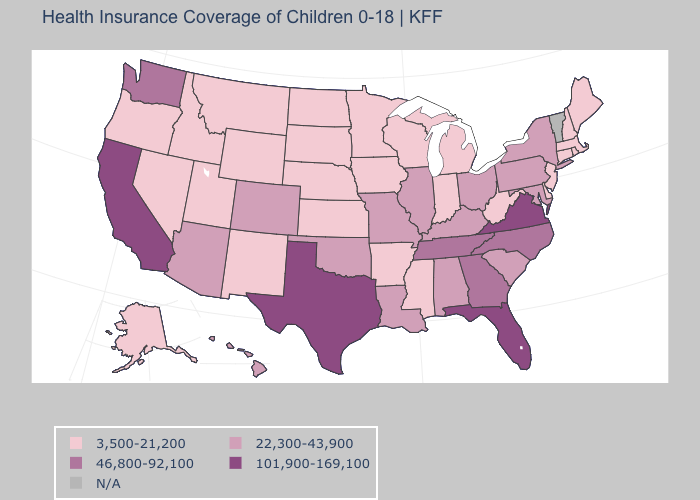Does the map have missing data?
Be succinct. Yes. Is the legend a continuous bar?
Give a very brief answer. No. Among the states that border Texas , which have the lowest value?
Short answer required. Arkansas, New Mexico. Among the states that border Idaho , does Utah have the lowest value?
Answer briefly. Yes. Name the states that have a value in the range 101,900-169,100?
Answer briefly. California, Florida, Texas, Virginia. Which states have the lowest value in the South?
Give a very brief answer. Arkansas, Delaware, Mississippi, West Virginia. Among the states that border Delaware , does Maryland have the highest value?
Give a very brief answer. Yes. What is the value of Wyoming?
Short answer required. 3,500-21,200. Which states have the lowest value in the USA?
Answer briefly. Alaska, Arkansas, Connecticut, Delaware, Idaho, Indiana, Iowa, Kansas, Maine, Massachusetts, Michigan, Minnesota, Mississippi, Montana, Nebraska, Nevada, New Hampshire, New Jersey, New Mexico, North Dakota, Oregon, Rhode Island, South Dakota, Utah, West Virginia, Wisconsin, Wyoming. Name the states that have a value in the range 46,800-92,100?
Concise answer only. Georgia, North Carolina, Tennessee, Washington. What is the highest value in states that border Utah?
Short answer required. 22,300-43,900. Among the states that border Kentucky , which have the highest value?
Be succinct. Virginia. 